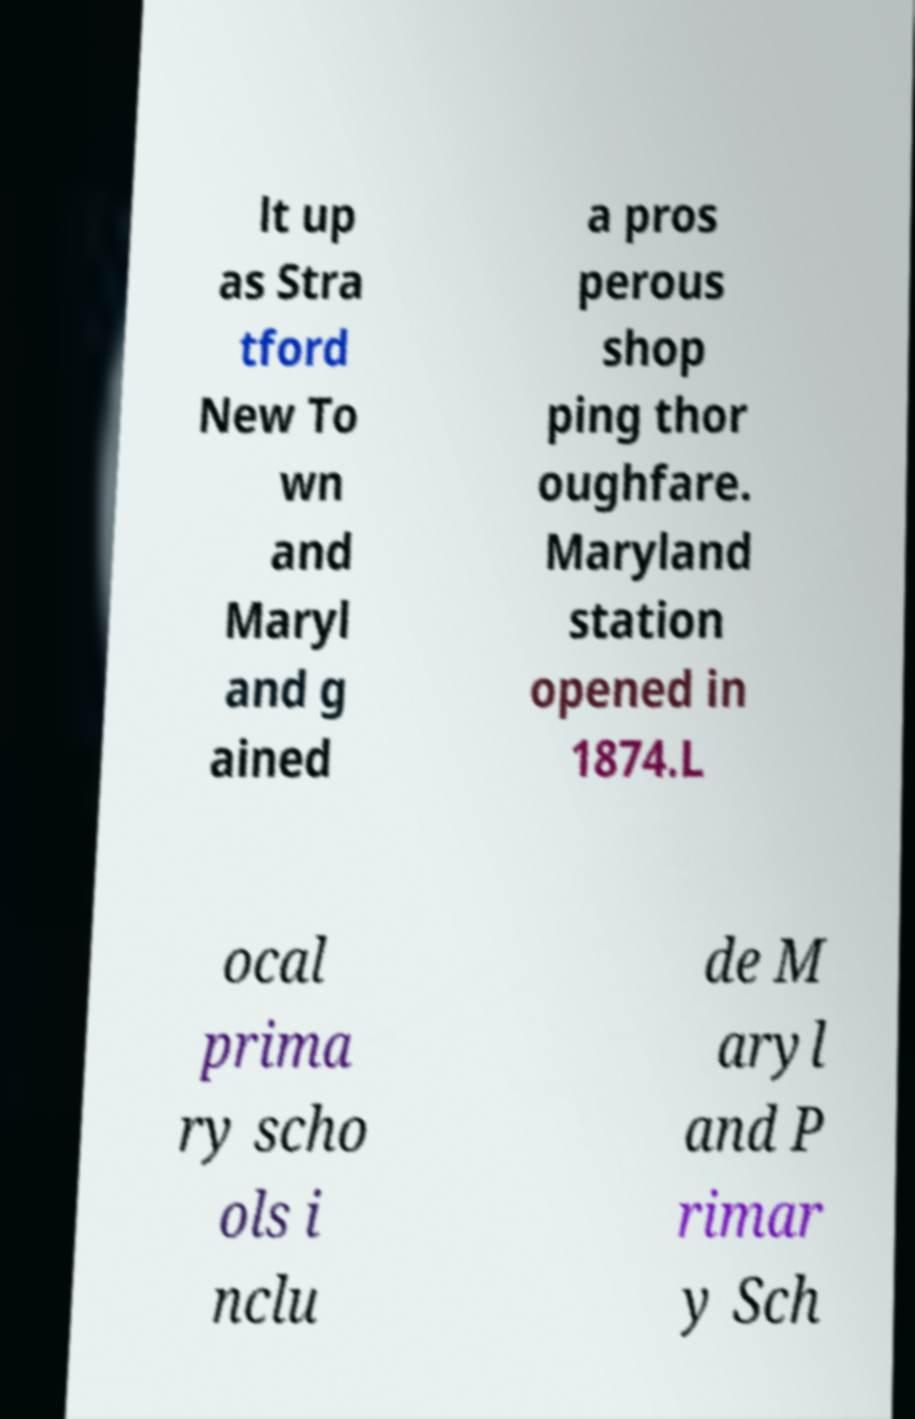Can you accurately transcribe the text from the provided image for me? lt up as Stra tford New To wn and Maryl and g ained a pros perous shop ping thor oughfare. Maryland station opened in 1874.L ocal prima ry scho ols i nclu de M aryl and P rimar y Sch 